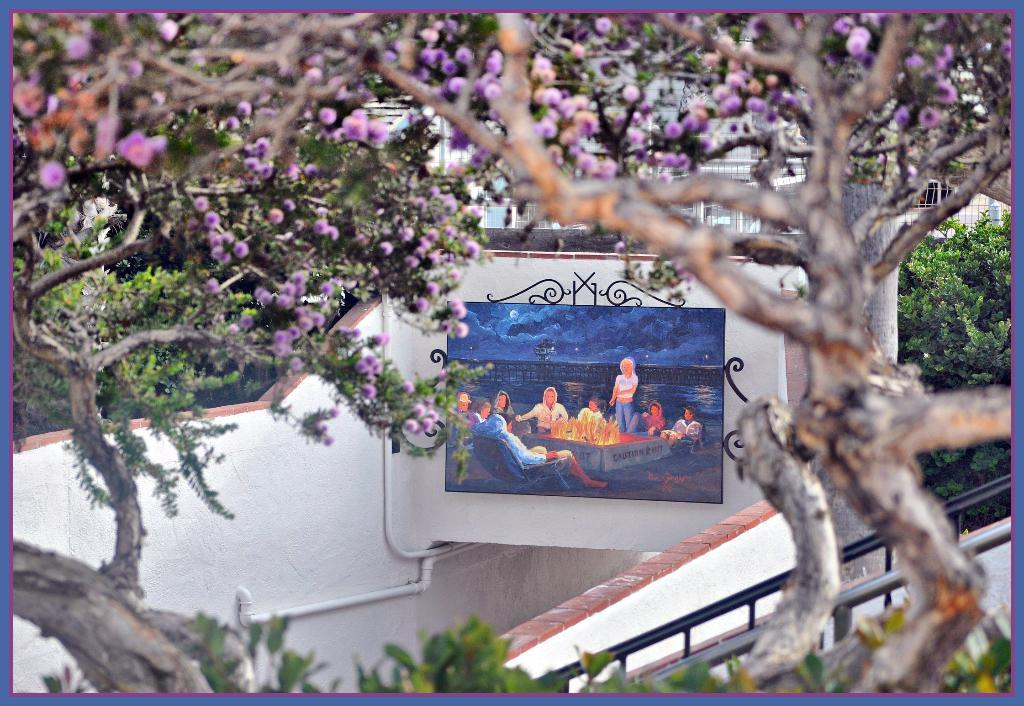What type of natural elements can be seen in the image? There are flowers in the image. What type of man-made structures are present in the image? There are walls, pipes, fences, a frame, and buildings visible in the image. What is the setting of the image? The image shows people and water in a frame, with sky visible in the background. What can be seen in the background of the image? There are buildings in the background of the image. What type of yard can be seen in the image? There is no yard present in the image. What color is the paint used on the laborer's clothes in the image? There is no laborer present in the image, and therefore no clothing to describe. 